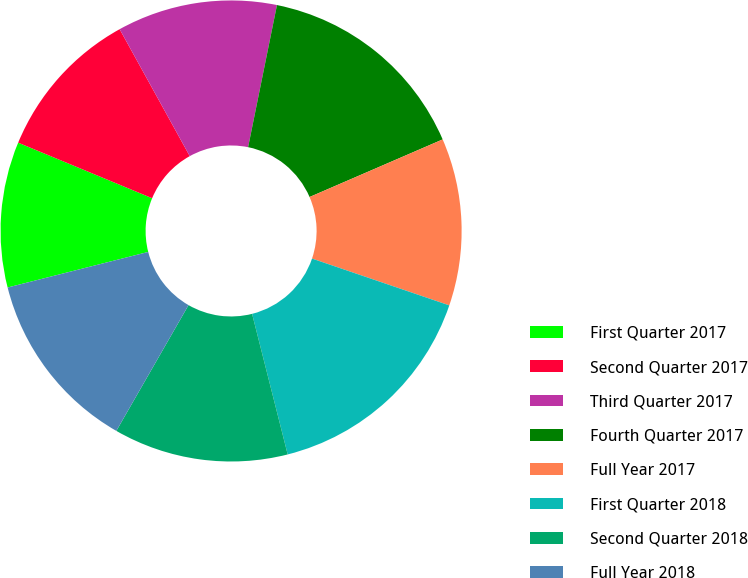<chart> <loc_0><loc_0><loc_500><loc_500><pie_chart><fcel>First Quarter 2017<fcel>Second Quarter 2017<fcel>Third Quarter 2017<fcel>Fourth Quarter 2017<fcel>Full Year 2017<fcel>First Quarter 2018<fcel>Second Quarter 2018<fcel>Full Year 2018<nl><fcel>10.2%<fcel>10.71%<fcel>11.22%<fcel>15.31%<fcel>11.73%<fcel>15.82%<fcel>12.24%<fcel>12.76%<nl></chart> 